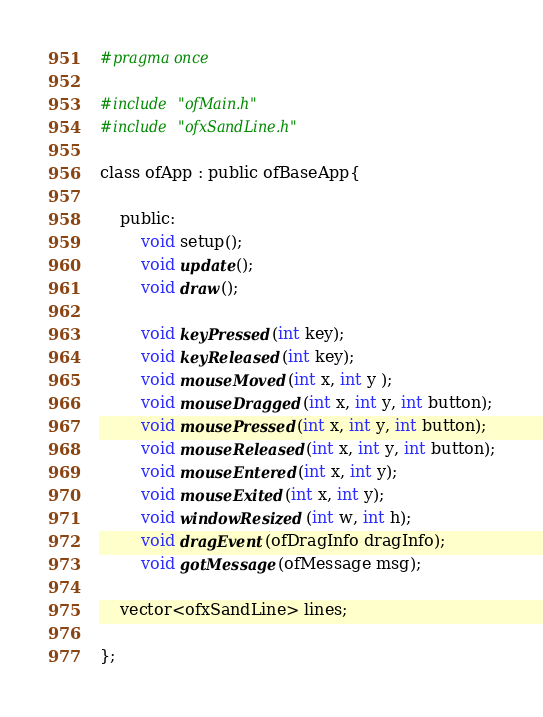<code> <loc_0><loc_0><loc_500><loc_500><_C_>#pragma once

#include "ofMain.h"
#include "ofxSandLine.h"

class ofApp : public ofBaseApp{

	public:
		void setup();
		void update();
		void draw();

		void keyPressed(int key);
		void keyReleased(int key);
		void mouseMoved(int x, int y );
		void mouseDragged(int x, int y, int button);
		void mousePressed(int x, int y, int button);
		void mouseReleased(int x, int y, int button);
		void mouseEntered(int x, int y);
		void mouseExited(int x, int y);
		void windowResized(int w, int h);
		void dragEvent(ofDragInfo dragInfo);
		void gotMessage(ofMessage msg);
    
    vector<ofxSandLine> lines;
		
};
</code> 